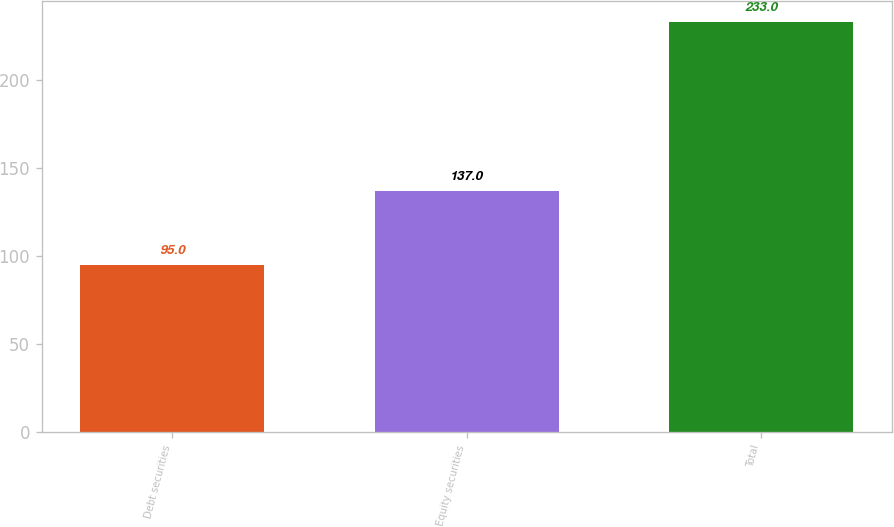Convert chart to OTSL. <chart><loc_0><loc_0><loc_500><loc_500><bar_chart><fcel>Debt securities<fcel>Equity securities<fcel>Total<nl><fcel>95<fcel>137<fcel>233<nl></chart> 